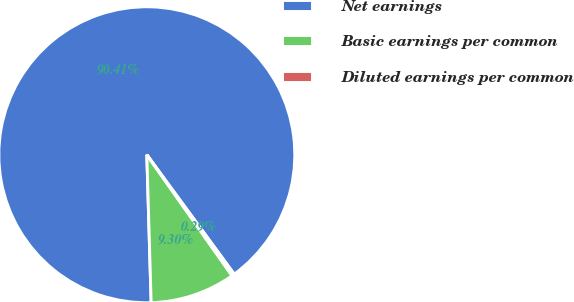<chart> <loc_0><loc_0><loc_500><loc_500><pie_chart><fcel>Net earnings<fcel>Basic earnings per common<fcel>Diluted earnings per common<nl><fcel>90.41%<fcel>9.3%<fcel>0.29%<nl></chart> 